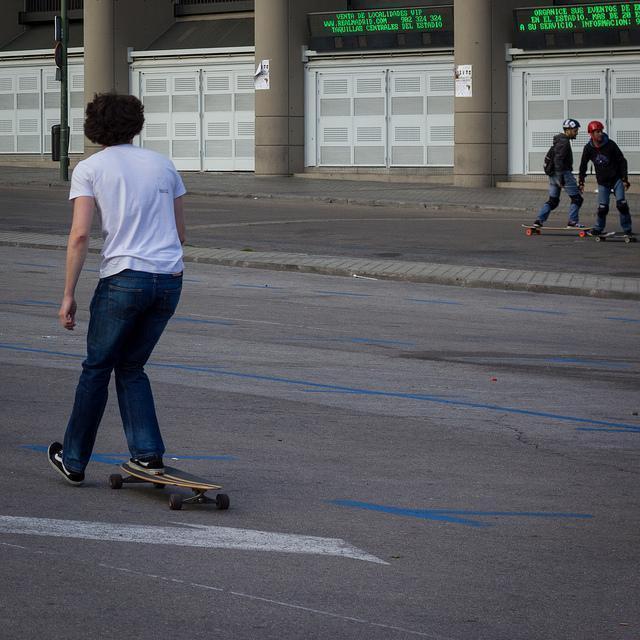What style of skateboard is the man in the white shirt using?
Choose the correct response and explain in the format: 'Answer: answer
Rationale: rationale.'
Options: Long board, radio board, vert board, hover board. Answer: long board.
Rationale: The board is not a traditional skateboard. it looks like an older "longboard" design from decades past. 